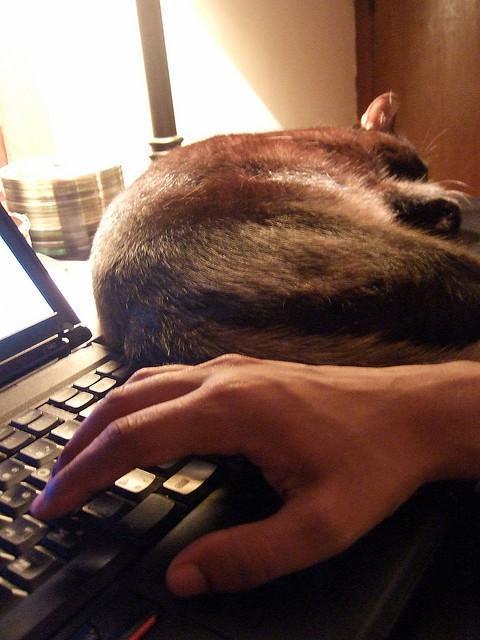How many cats are the person's arm?
Give a very brief answer. 1. 